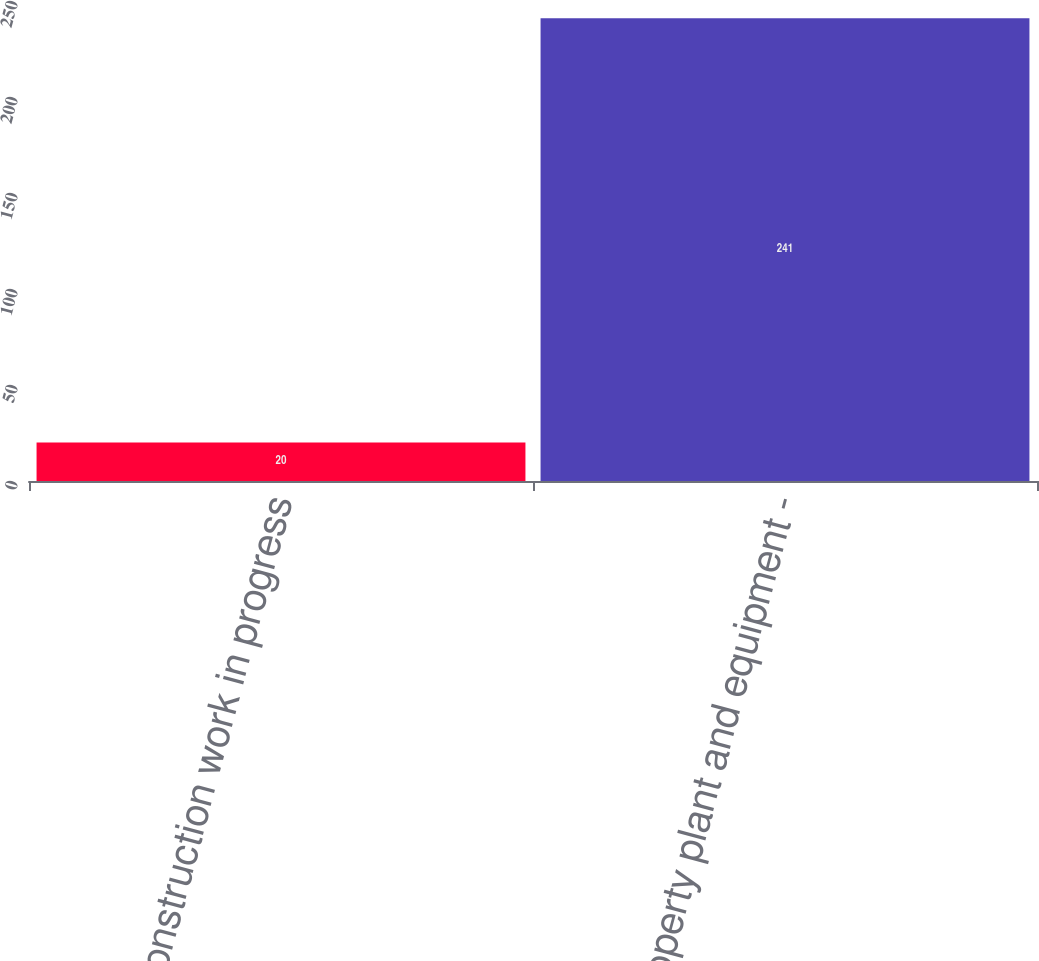Convert chart. <chart><loc_0><loc_0><loc_500><loc_500><bar_chart><fcel>Construction work in progress<fcel>Property plant and equipment -<nl><fcel>20<fcel>241<nl></chart> 